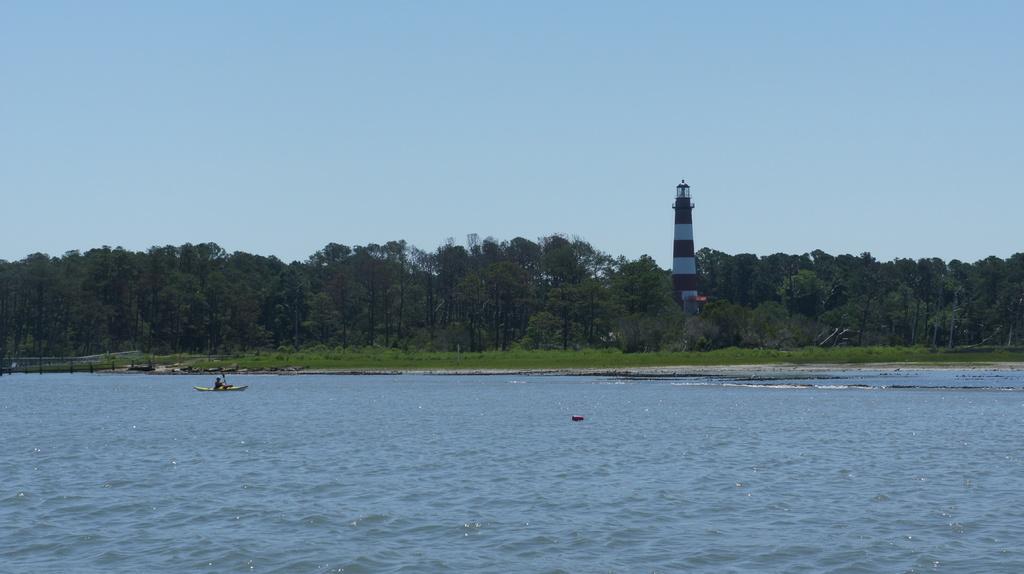Please provide a concise description of this image. In this image a person is sitting on the boat. He is holding a raft in his hand. Boat is sailing on water. Left side there is a fence. Middle of image there is a tower on land having few plants and trees. Top of the image there is sky. 